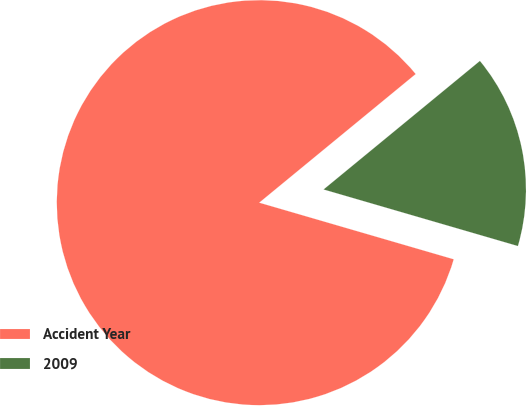<chart> <loc_0><loc_0><loc_500><loc_500><pie_chart><fcel>Accident Year<fcel>2009<nl><fcel>84.54%<fcel>15.46%<nl></chart> 